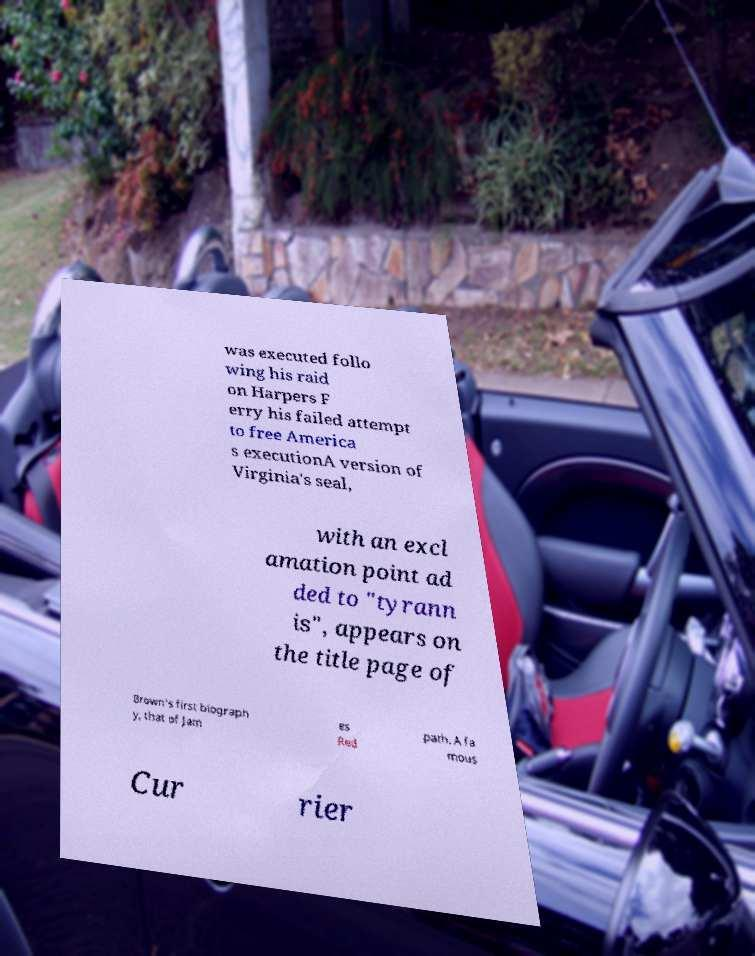Can you accurately transcribe the text from the provided image for me? was executed follo wing his raid on Harpers F erry his failed attempt to free America s executionA version of Virginia's seal, with an excl amation point ad ded to "tyrann is", appears on the title page of Brown's first biograph y, that of Jam es Red path. A fa mous Cur rier 